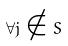Convert formula to latex. <formula><loc_0><loc_0><loc_500><loc_500>\forall j \notin S</formula> 